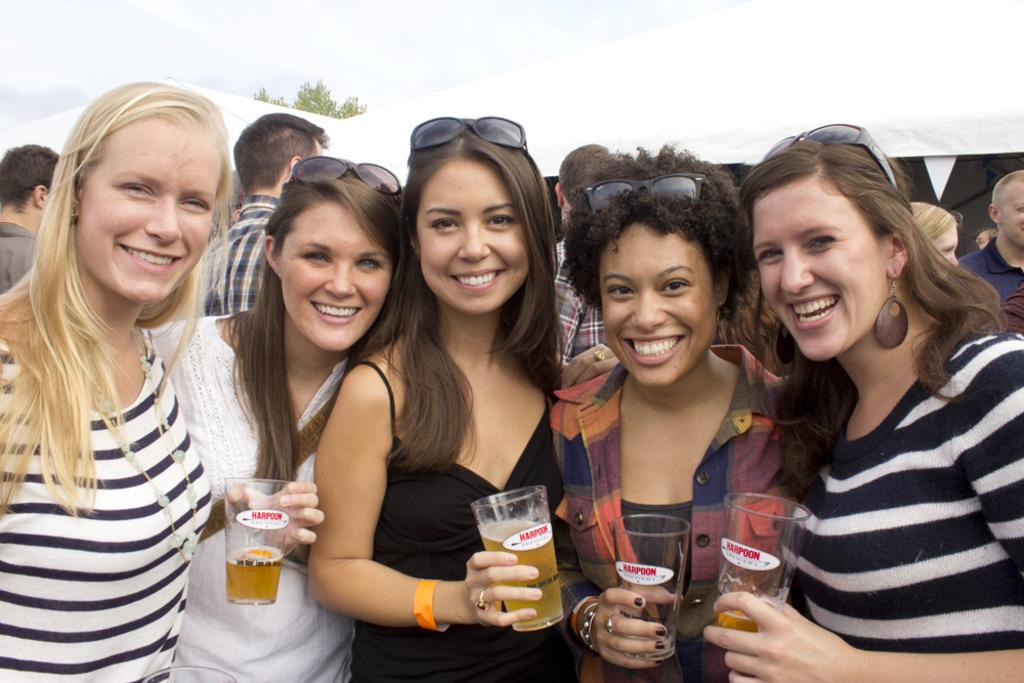What is the main subject of the image? The main subject of the image is a group of girls. What are the girls doing in the image? The girls are standing in the image. What are the girls holding in their hands? The girls are holding wine glasses in the image. Can you describe the background of the image? There are many members standing in the background, and the sky is visible in the image. What type of hair can be seen on the girls in the image? There is no information about the girls' hair in the image. --- Facts: 1. There is a car in the image. 2. The car is red. 3. The car has four doors. 4. The car has a sunroof. 5. The car has a spoiler. Absurd Topics: bicycle, skateboard Conversation: What is the main subject in the image? The main subject in the image is a car. What color is the car? The car is red. How many doors does the car have? The car has four doors. What additional feature does the car have? The car has a sunroof. Does the car have any other notable features? Yes, the car has a spoiler. Reasoning: Let's think step by step in order to produce the conversation. We start by identifying the main subject of the image, which is the car. Next, we describe specific features of the car, such as its color, the number of doors, and the presence of a sunroof and a spoiler. Each question is designed to elicit a specific detail about the image that is known from the provided facts. Absurd Question/Answer: Can you see any bicycles or skateboards in the image? No, there are no bicycles or skateboards visible in the image. 